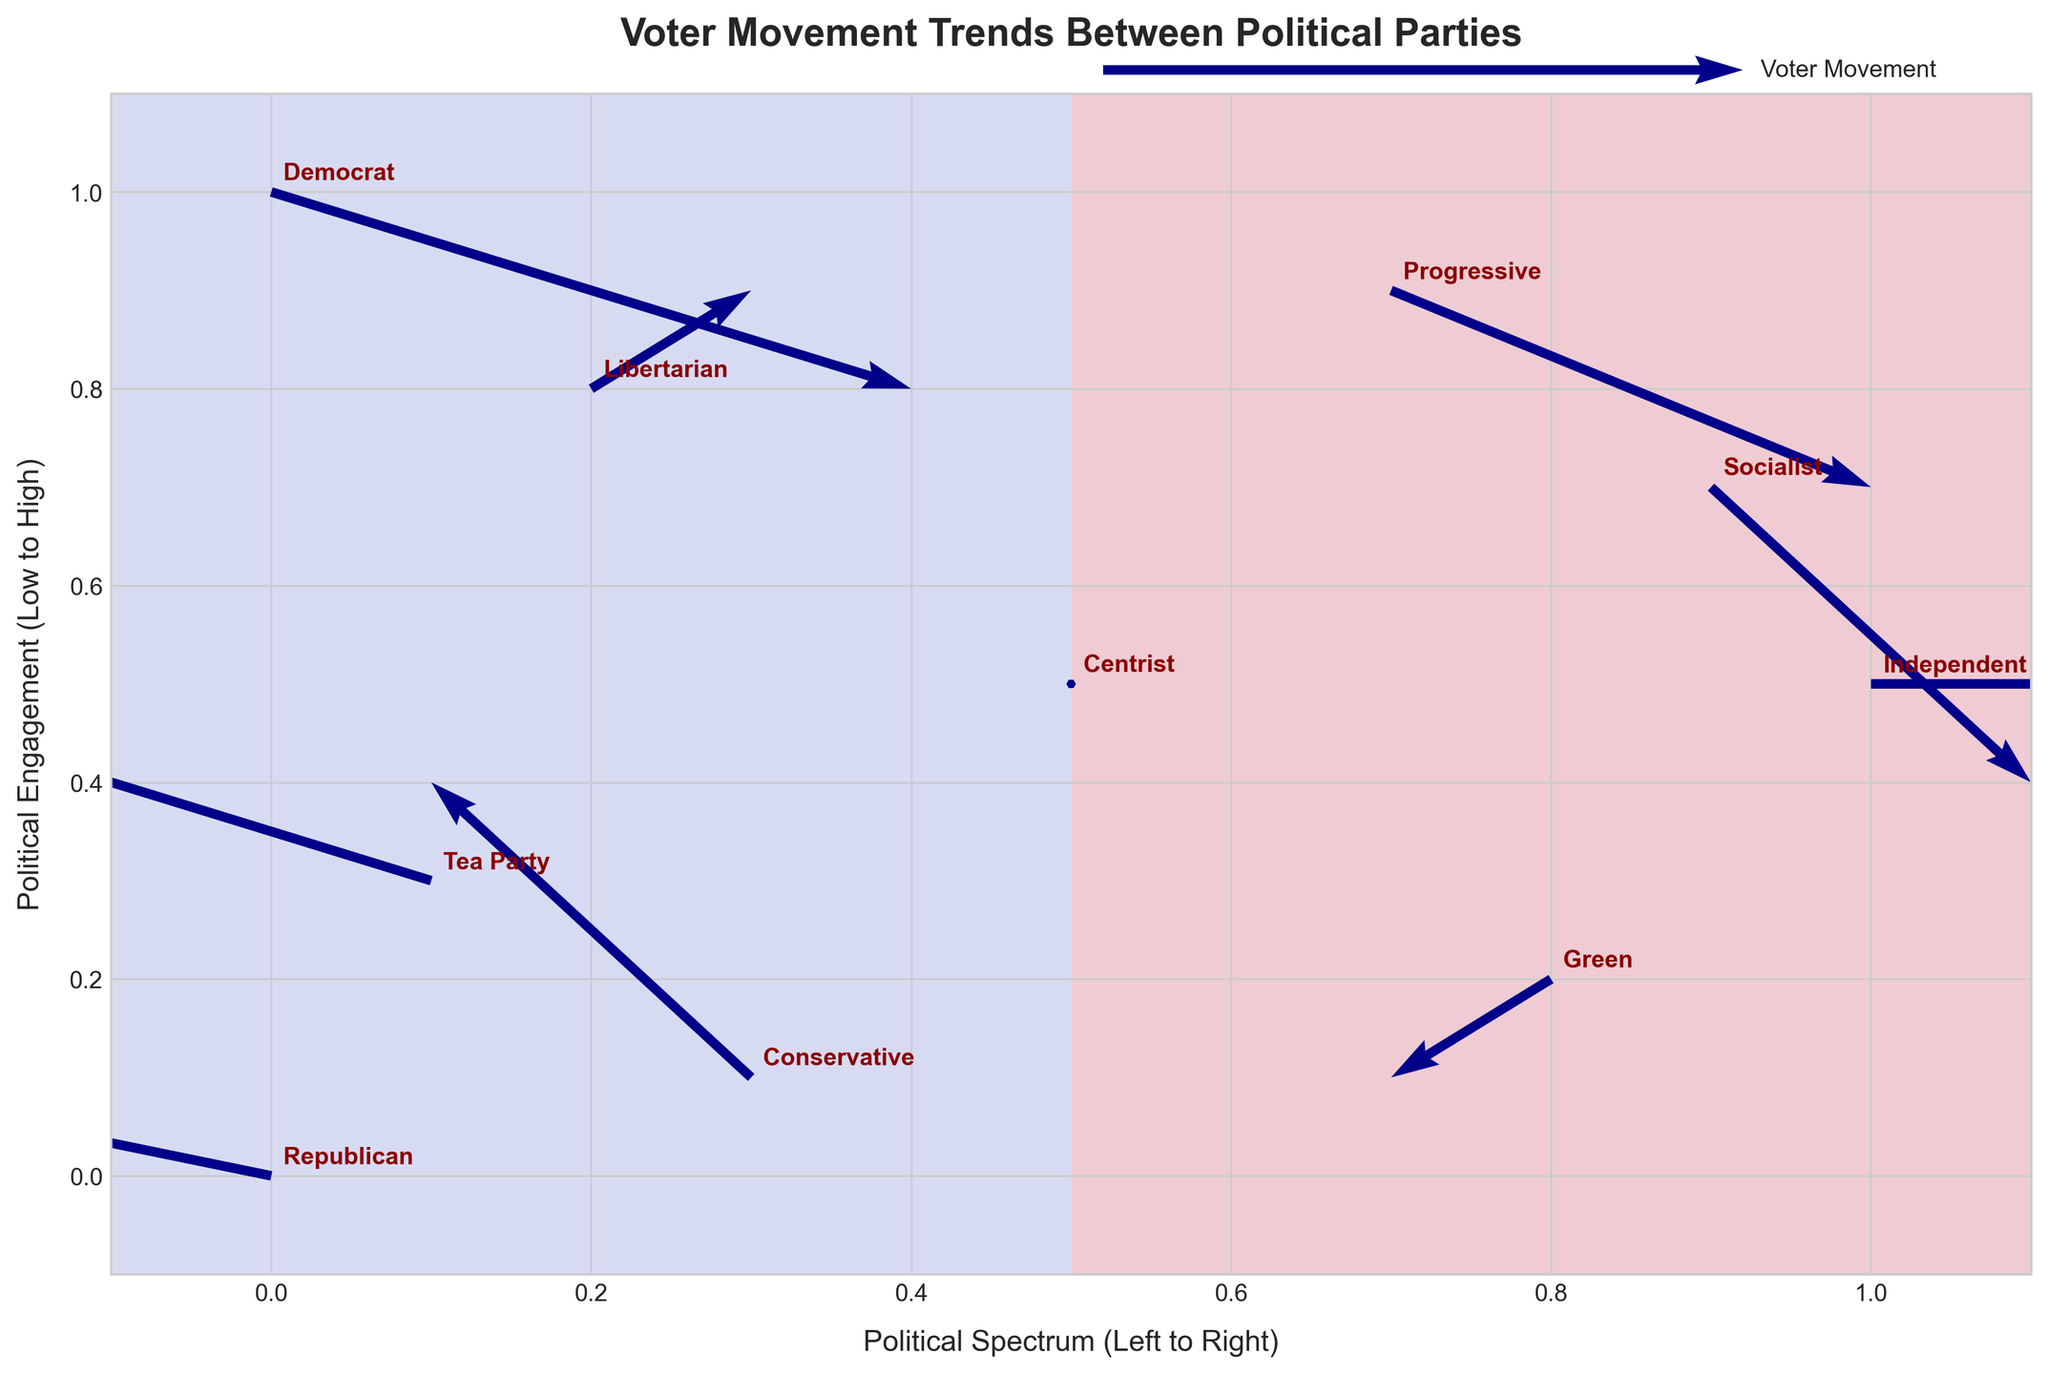What is the title of the plot? The title is located at the top center of the plot and it says, "Voter Movement Trends Between Political Parties".
Answer: Voter Movement Trends Between Political Parties How many political parties are represented in the plot? Each annotated label represents a political party. By counting each label we can see there are ten parties.
Answer: Ten Which political party shows the largest movement towards the left on the political spectrum? Looking at the arrows, the Tea Party has the most significant horizontal leftward movement (U value of -0.2).
Answer: Tea Party Which party has the strongest upward movement in political engagement? The Conservative party has the most significant positive V value when looking at upward movements.
Answer: Conservative What is the direction of voter movement for the Progressive party? Check the arrow originating from the Progressive party's position. It points somewhat downwards and to the right (U=0.15, V=-0.1).
Answer: Downwards and to the right Which two parties have no significant movement (U and V are both zero)? Find the arrows with both components as zero, which is only the Centrist party.
Answer: Centrist Comparing the Democrat and Libertarian parties, which one shows stronger engagement (vertical movement)? The Libertarian party has a positive V value of 0.05, while the Democrat has a negative V value of -0.1. Therefore, the Libertarian party shows stronger engagement.
Answer: Libertarian Which party shows downward movement in political engagement but slight rightward movement on the spectrum? The Socialist party's arrow points downwards and slightly to the right (U=0.1, V=-0.15).
Answer: Socialist What is the overall trend for voter movement among the right-leaning parties (Republican, Tea Party, and Conservative)? By analyzing the arrows: 
   - Republican moves towards the left and slightly upward. 
   - Tea Party moves primarily to the left and slightly upward.
   - Conservative moves upward. 
The trend indicates a left and upward direction overall.
Answer: Left and upward 